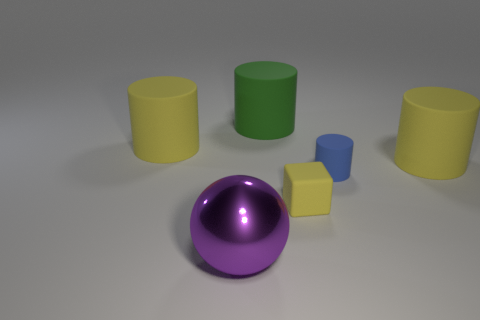Subtract all large cylinders. How many cylinders are left? 1 Subtract 1 cylinders. How many cylinders are left? 3 Add 4 large brown metallic cylinders. How many objects exist? 10 Subtract all yellow cylinders. How many cylinders are left? 2 Subtract 0 red cubes. How many objects are left? 6 Subtract all spheres. How many objects are left? 5 Subtract all cyan cylinders. Subtract all green balls. How many cylinders are left? 4 Subtract all blue balls. How many blue cubes are left? 0 Subtract all yellow rubber blocks. Subtract all blue things. How many objects are left? 4 Add 6 tiny yellow rubber blocks. How many tiny yellow rubber blocks are left? 7 